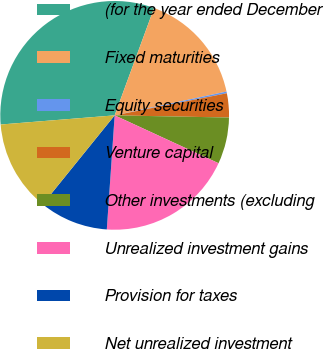Convert chart to OTSL. <chart><loc_0><loc_0><loc_500><loc_500><pie_chart><fcel>(for the year ended December<fcel>Fixed maturities<fcel>Equity securities<fcel>Venture capital<fcel>Other investments (excluding<fcel>Unrealized investment gains<fcel>Provision for taxes<fcel>Net unrealized investment<nl><fcel>31.88%<fcel>16.06%<fcel>0.24%<fcel>3.4%<fcel>6.57%<fcel>19.22%<fcel>9.73%<fcel>12.9%<nl></chart> 